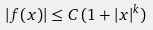Convert formula to latex. <formula><loc_0><loc_0><loc_500><loc_500>| f ( x ) | \leq C \, ( 1 + | x | ^ { k } )</formula> 